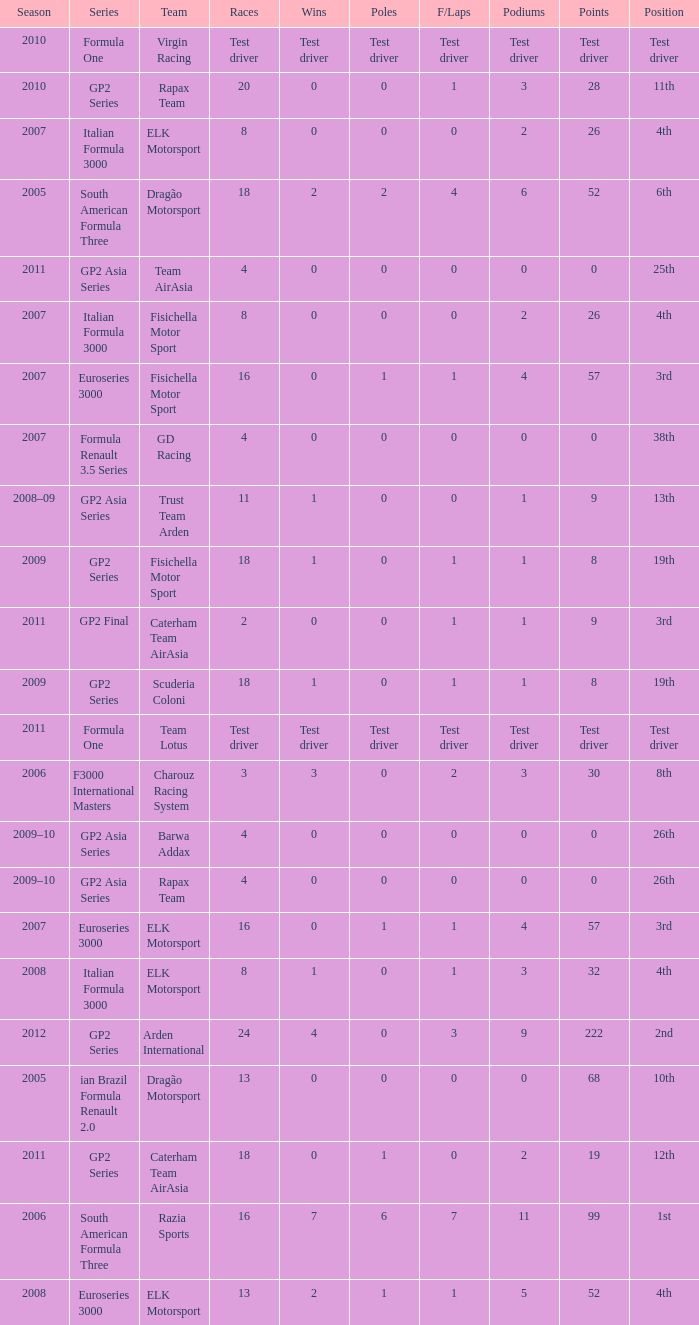What was the F/Laps when the Wins were 0 and the Position was 4th? 0, 0. 